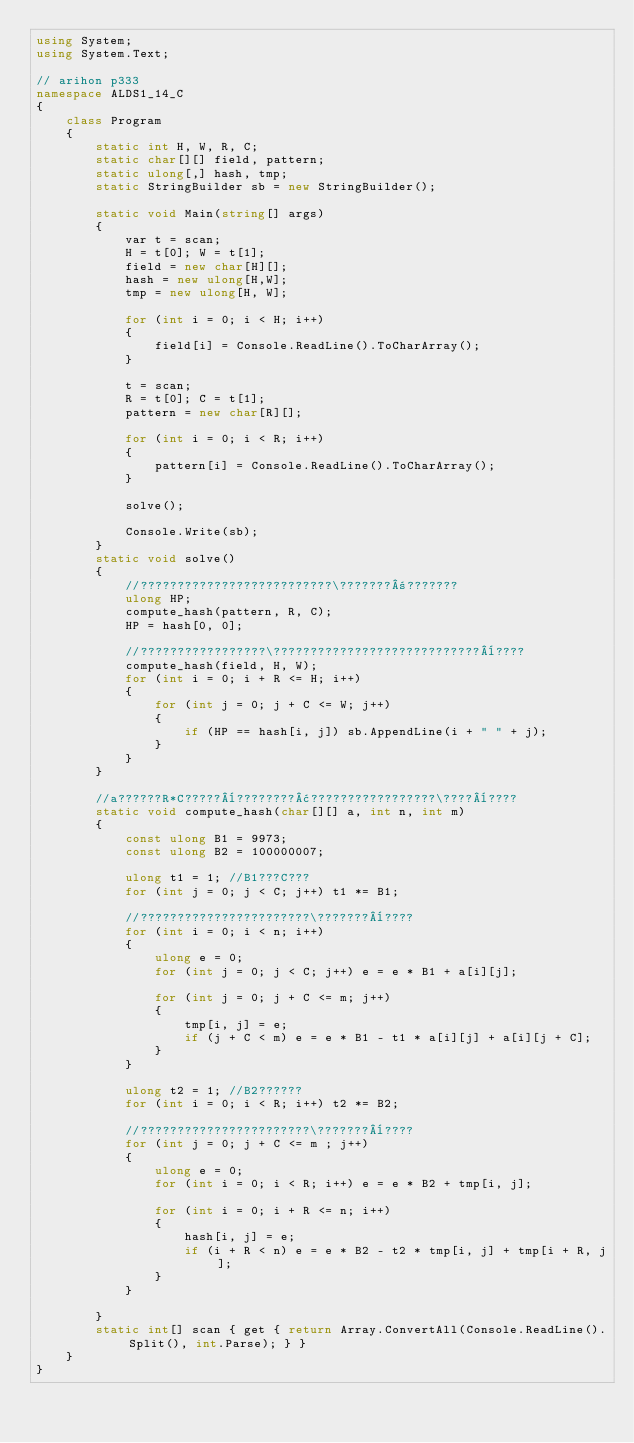<code> <loc_0><loc_0><loc_500><loc_500><_C#_>using System;
using System.Text;

// arihon p333
namespace ALDS1_14_C
{
    class Program
    {
        static int H, W, R, C;
        static char[][] field, pattern;
        static ulong[,] hash, tmp;
        static StringBuilder sb = new StringBuilder();

        static void Main(string[] args)
        {
            var t = scan;
            H = t[0]; W = t[1];
            field = new char[H][];
            hash = new ulong[H,W];
            tmp = new ulong[H, W];

            for (int i = 0; i < H; i++)
            {
                field[i] = Console.ReadLine().ToCharArray();
            }

            t = scan;
            R = t[0]; C = t[1];
            pattern = new char[R][];

            for (int i = 0; i < R; i++)
            {
                pattern[i] = Console.ReadLine().ToCharArray();
            }

            solve();

            Console.Write(sb);
        }
        static void solve()
        {
            //??????????????????????????\???????±???????
            ulong HP;
            compute_hash(pattern, R, C);
            HP = hash[0, 0];

            //?????????????????\????????????????????????????¨????
            compute_hash(field, H, W);
            for (int i = 0; i + R <= H; i++)
            {
                for (int j = 0; j + C <= W; j++)
                {
                    if (HP == hash[i, j]) sb.AppendLine(i + " " + j);
                }
            }
        }

        //a??????R*C?????¨????????¢?????????????????\????¨????
        static void compute_hash(char[][] a, int n, int m)
        {
            const ulong B1 = 9973;
            const ulong B2 = 100000007;

            ulong t1 = 1; //B1???C???
            for (int j = 0; j < C; j++) t1 *= B1;

            //???????????????????????\???????¨????
            for (int i = 0; i < n; i++)
            {
                ulong e = 0;
                for (int j = 0; j < C; j++) e = e * B1 + a[i][j];

                for (int j = 0; j + C <= m; j++)
                {
                    tmp[i, j] = e;
                    if (j + C < m) e = e * B1 - t1 * a[i][j] + a[i][j + C];
                }
            }

            ulong t2 = 1; //B2??????
            for (int i = 0; i < R; i++) t2 *= B2;

            //???????????????????????\???????¨????
            for (int j = 0; j + C <= m ; j++)
            {
                ulong e = 0;
                for (int i = 0; i < R; i++) e = e * B2 + tmp[i, j];

                for (int i = 0; i + R <= n; i++)
                {
                    hash[i, j] = e;
                    if (i + R < n) e = e * B2 - t2 * tmp[i, j] + tmp[i + R, j];
                }
            }

        }
        static int[] scan { get { return Array.ConvertAll(Console.ReadLine().Split(), int.Parse); } }
    }
}</code> 